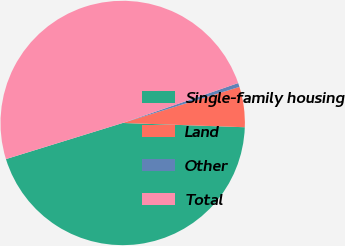Convert chart. <chart><loc_0><loc_0><loc_500><loc_500><pie_chart><fcel>Single-family housing<fcel>Land<fcel>Other<fcel>Total<nl><fcel>44.67%<fcel>5.33%<fcel>0.52%<fcel>49.48%<nl></chart> 